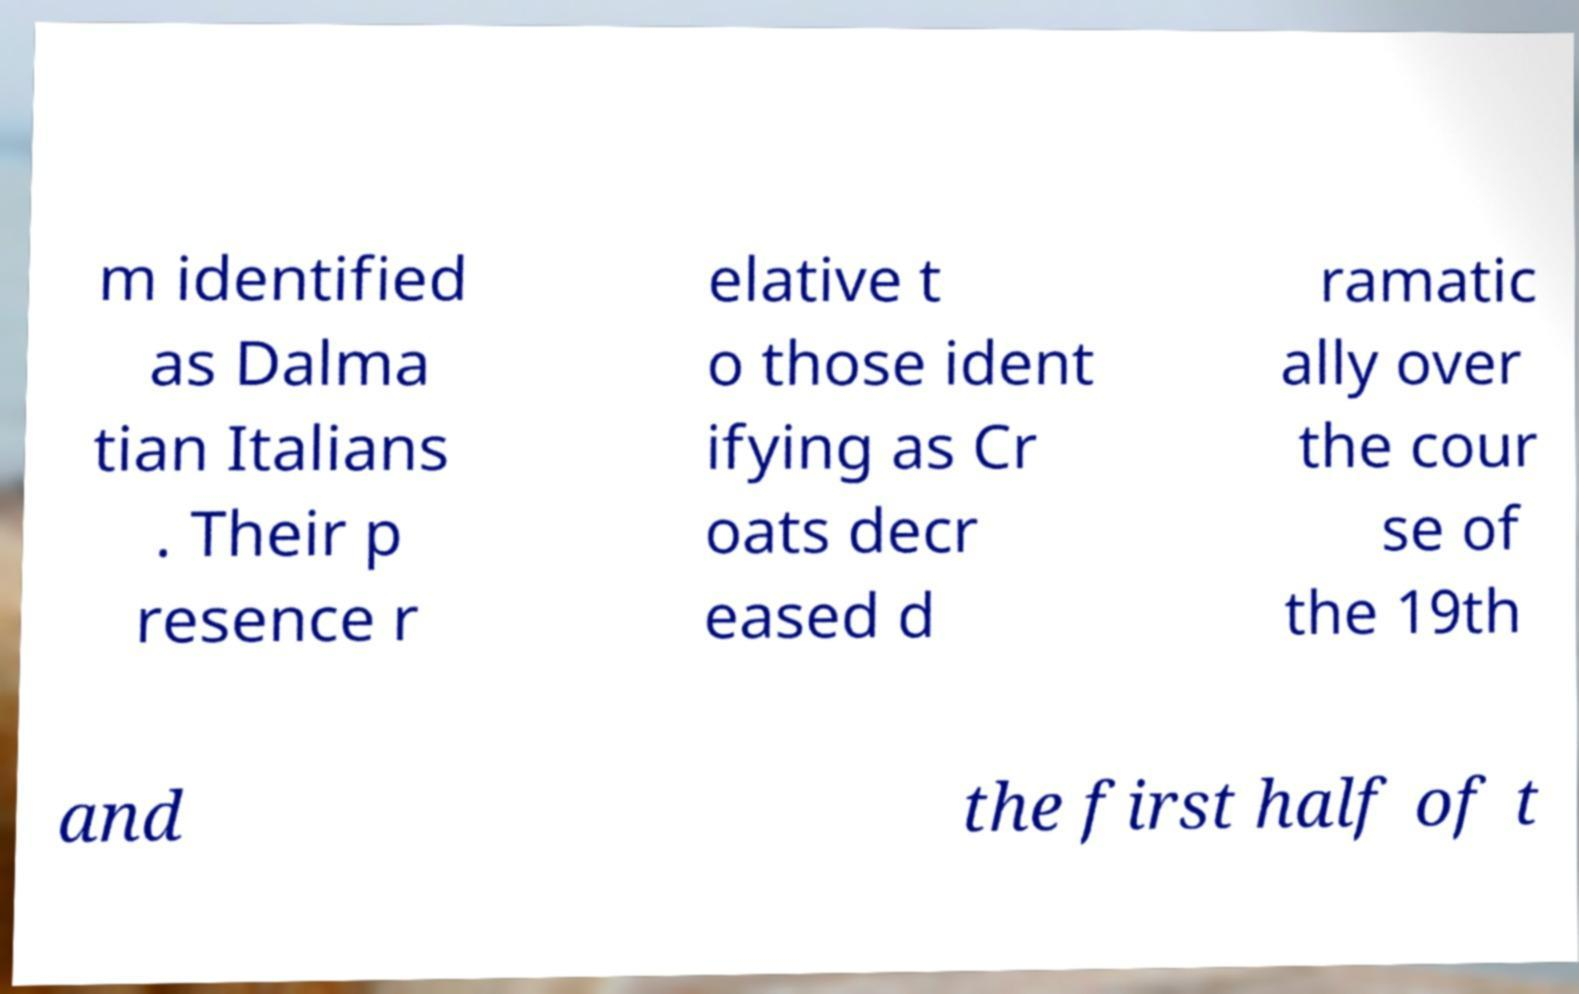There's text embedded in this image that I need extracted. Can you transcribe it verbatim? m identified as Dalma tian Italians . Their p resence r elative t o those ident ifying as Cr oats decr eased d ramatic ally over the cour se of the 19th and the first half of t 